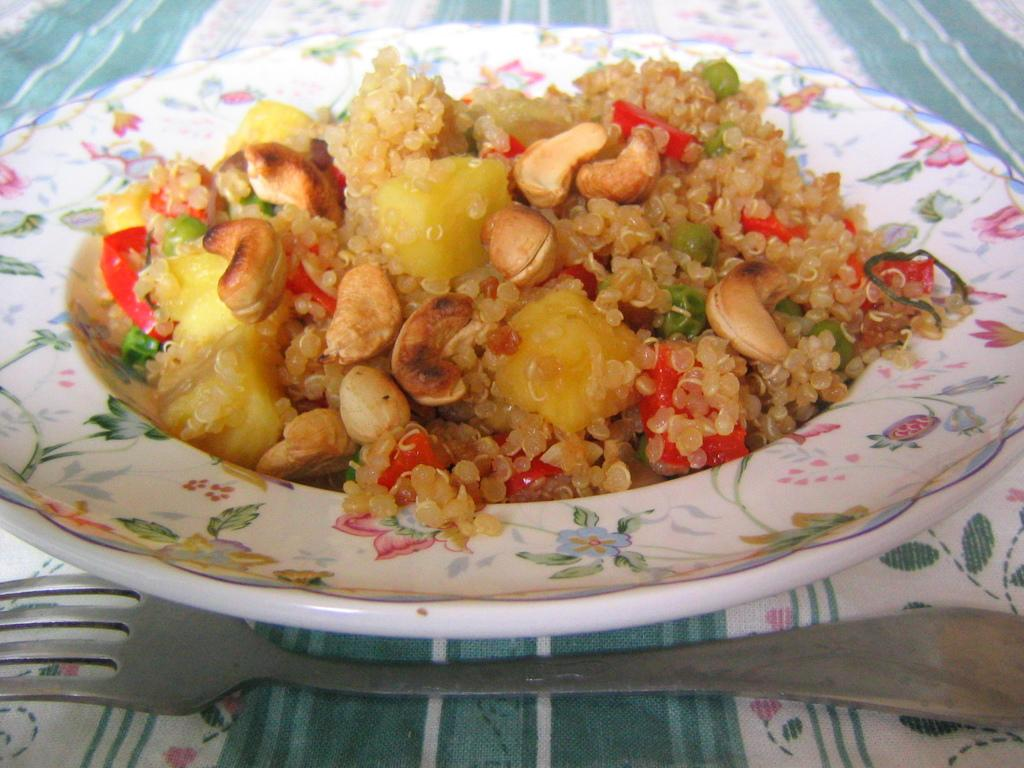What is the main food item visible on the plate in the image? Unfortunately, the specific food item cannot be determined from the provided facts. What utensil is present on the cloth in the image? There is a fork on the cloth in the image. What type of instrument is being played in the image? There is no instrument present in the image. How many cards are visible on the table in the image? There is no mention of cards in the provided facts, so it cannot be determined if any are present in the image. 